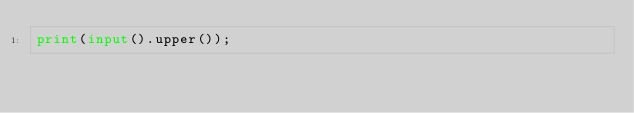<code> <loc_0><loc_0><loc_500><loc_500><_Python_>print(input().upper());</code> 